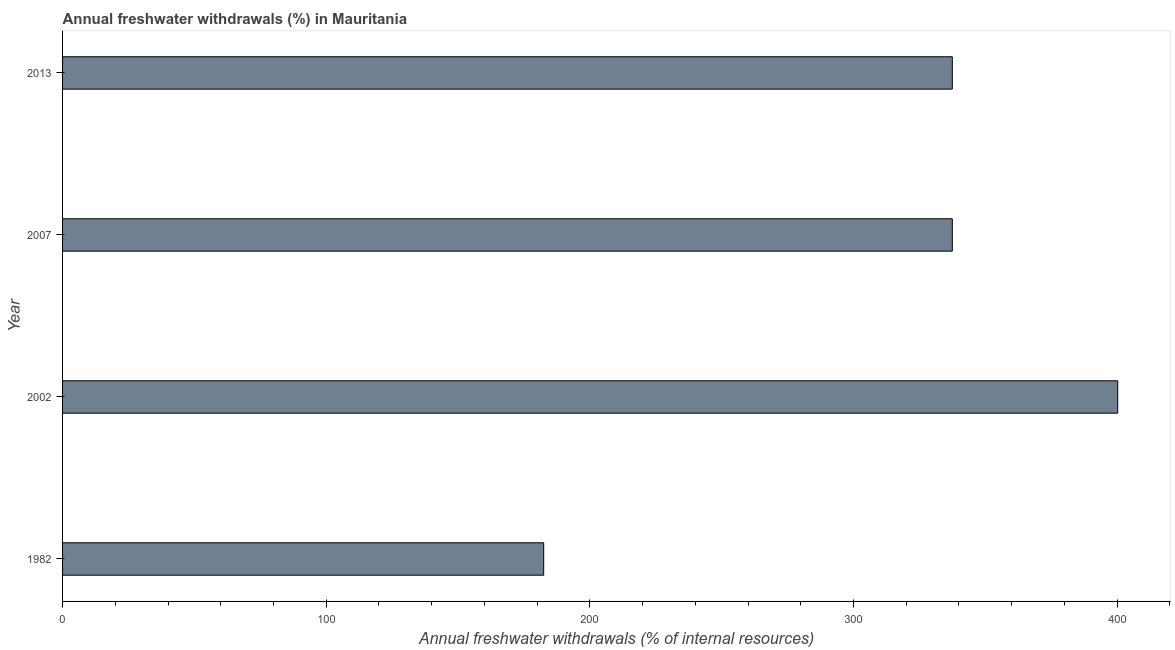What is the title of the graph?
Ensure brevity in your answer.  Annual freshwater withdrawals (%) in Mauritania. What is the label or title of the X-axis?
Your answer should be compact. Annual freshwater withdrawals (% of internal resources). What is the annual freshwater withdrawals in 2013?
Offer a terse response. 337.5. Across all years, what is the maximum annual freshwater withdrawals?
Ensure brevity in your answer.  400.25. Across all years, what is the minimum annual freshwater withdrawals?
Offer a very short reply. 182.5. In which year was the annual freshwater withdrawals maximum?
Keep it short and to the point. 2002. What is the sum of the annual freshwater withdrawals?
Ensure brevity in your answer.  1257.75. What is the difference between the annual freshwater withdrawals in 2002 and 2007?
Provide a short and direct response. 62.75. What is the average annual freshwater withdrawals per year?
Provide a succinct answer. 314.44. What is the median annual freshwater withdrawals?
Offer a very short reply. 337.5. In how many years, is the annual freshwater withdrawals greater than 200 %?
Provide a succinct answer. 3. Do a majority of the years between 2002 and 1982 (inclusive) have annual freshwater withdrawals greater than 180 %?
Provide a succinct answer. No. What is the ratio of the annual freshwater withdrawals in 1982 to that in 2002?
Provide a short and direct response. 0.46. What is the difference between the highest and the second highest annual freshwater withdrawals?
Offer a very short reply. 62.75. What is the difference between the highest and the lowest annual freshwater withdrawals?
Make the answer very short. 217.75. How many bars are there?
Make the answer very short. 4. Are all the bars in the graph horizontal?
Keep it short and to the point. Yes. Are the values on the major ticks of X-axis written in scientific E-notation?
Provide a short and direct response. No. What is the Annual freshwater withdrawals (% of internal resources) in 1982?
Provide a succinct answer. 182.5. What is the Annual freshwater withdrawals (% of internal resources) of 2002?
Your answer should be compact. 400.25. What is the Annual freshwater withdrawals (% of internal resources) of 2007?
Ensure brevity in your answer.  337.5. What is the Annual freshwater withdrawals (% of internal resources) of 2013?
Offer a terse response. 337.5. What is the difference between the Annual freshwater withdrawals (% of internal resources) in 1982 and 2002?
Provide a short and direct response. -217.75. What is the difference between the Annual freshwater withdrawals (% of internal resources) in 1982 and 2007?
Make the answer very short. -155. What is the difference between the Annual freshwater withdrawals (% of internal resources) in 1982 and 2013?
Offer a very short reply. -155. What is the difference between the Annual freshwater withdrawals (% of internal resources) in 2002 and 2007?
Keep it short and to the point. 62.75. What is the difference between the Annual freshwater withdrawals (% of internal resources) in 2002 and 2013?
Keep it short and to the point. 62.75. What is the difference between the Annual freshwater withdrawals (% of internal resources) in 2007 and 2013?
Keep it short and to the point. 0. What is the ratio of the Annual freshwater withdrawals (% of internal resources) in 1982 to that in 2002?
Provide a succinct answer. 0.46. What is the ratio of the Annual freshwater withdrawals (% of internal resources) in 1982 to that in 2007?
Provide a short and direct response. 0.54. What is the ratio of the Annual freshwater withdrawals (% of internal resources) in 1982 to that in 2013?
Your answer should be very brief. 0.54. What is the ratio of the Annual freshwater withdrawals (% of internal resources) in 2002 to that in 2007?
Your answer should be very brief. 1.19. What is the ratio of the Annual freshwater withdrawals (% of internal resources) in 2002 to that in 2013?
Ensure brevity in your answer.  1.19. 